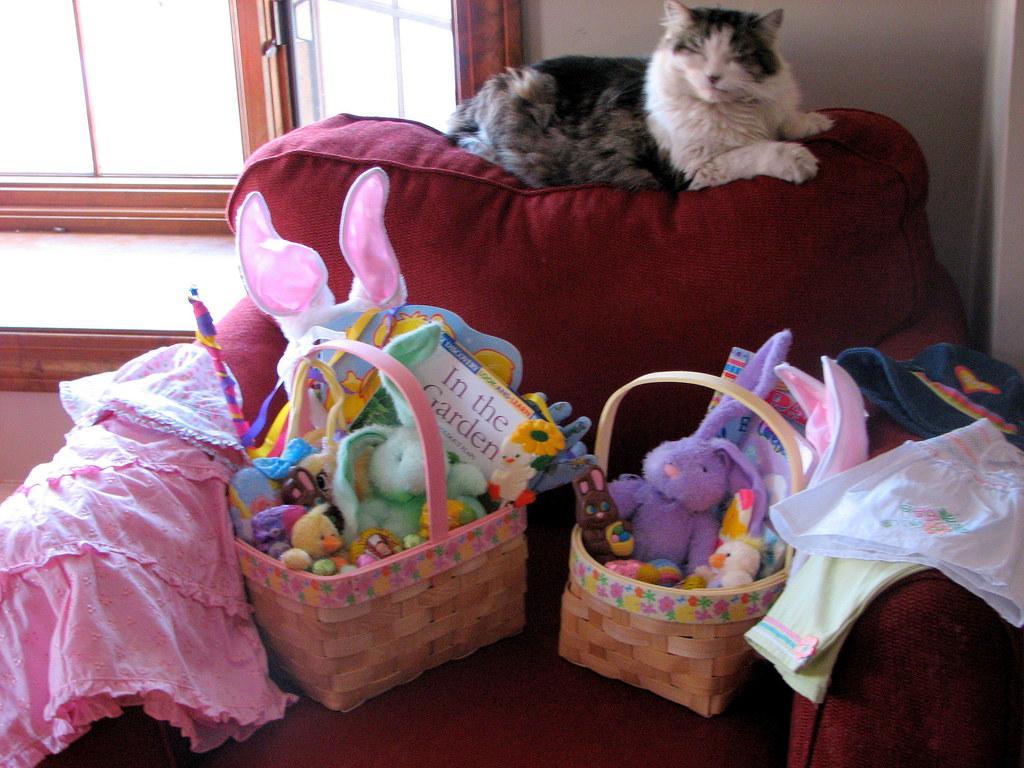Please provide a concise description of this image. In this picture we can see a chair and on the chair there are basket and clothes and in the baskets there are some toys and a cat is laying on the chair. Behind the cat there is a wall with a window. 